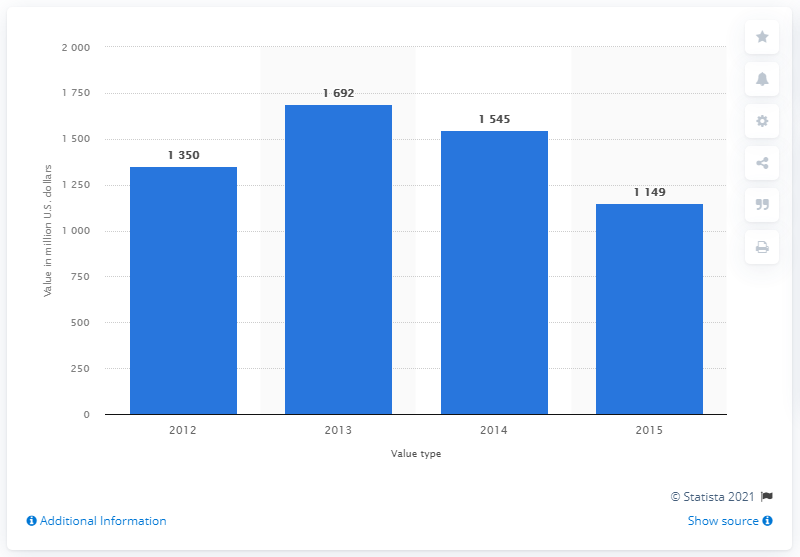Specify some key components in this picture. In 2015, lululemon's brand value was estimated to be 1149. 